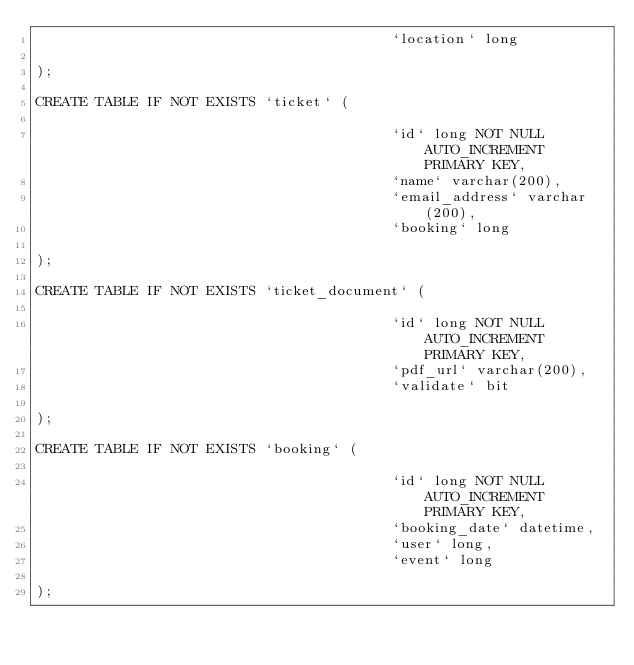<code> <loc_0><loc_0><loc_500><loc_500><_SQL_>                                          `location` long

);

CREATE TABLE IF NOT EXISTS `ticket` (

                                          `id` long NOT NULL AUTO_INCREMENT PRIMARY KEY,
                                          `name` varchar(200),
                                          `email_address` varchar(200),
                                          `booking` long

);

CREATE TABLE IF NOT EXISTS `ticket_document` (

                                          `id` long NOT NULL AUTO_INCREMENT PRIMARY KEY,
                                          `pdf_url` varchar(200),
                                          `validate` bit

);

CREATE TABLE IF NOT EXISTS `booking` (

                                          `id` long NOT NULL AUTO_INCREMENT PRIMARY KEY,
                                          `booking_date` datetime,
                                          `user` long,
                                          `event` long

);</code> 